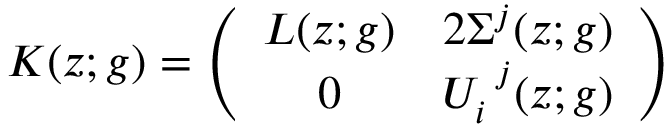Convert formula to latex. <formula><loc_0><loc_0><loc_500><loc_500>K ( z ; g ) = \left ( \begin{array} { c c } { L ( z ; g ) } & { { 2 \Sigma ^ { j } ( z ; g ) } } \\ { 0 } & { { U _ { i } ^ { j } ( z ; g ) } } \end{array} \right )</formula> 